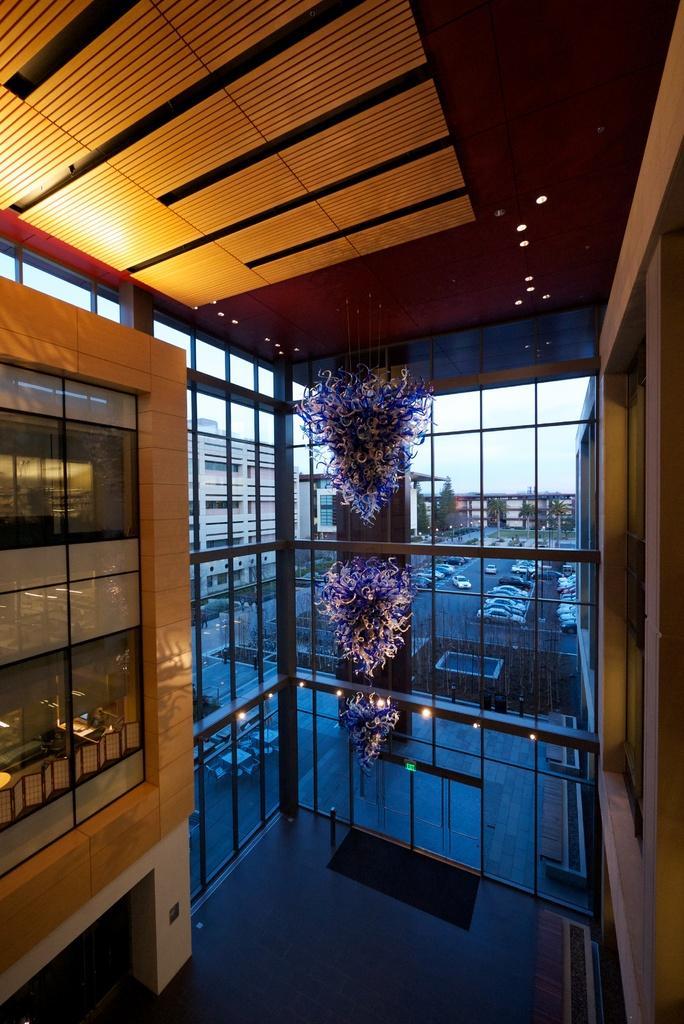Please provide a concise description of this image. This is inside view of a building. In this image we can see some decorations with flowers. Also there are doors. On the floor there is carpet. There are lights. Through the glass we can see vehicles, buildings, trees and sky. 